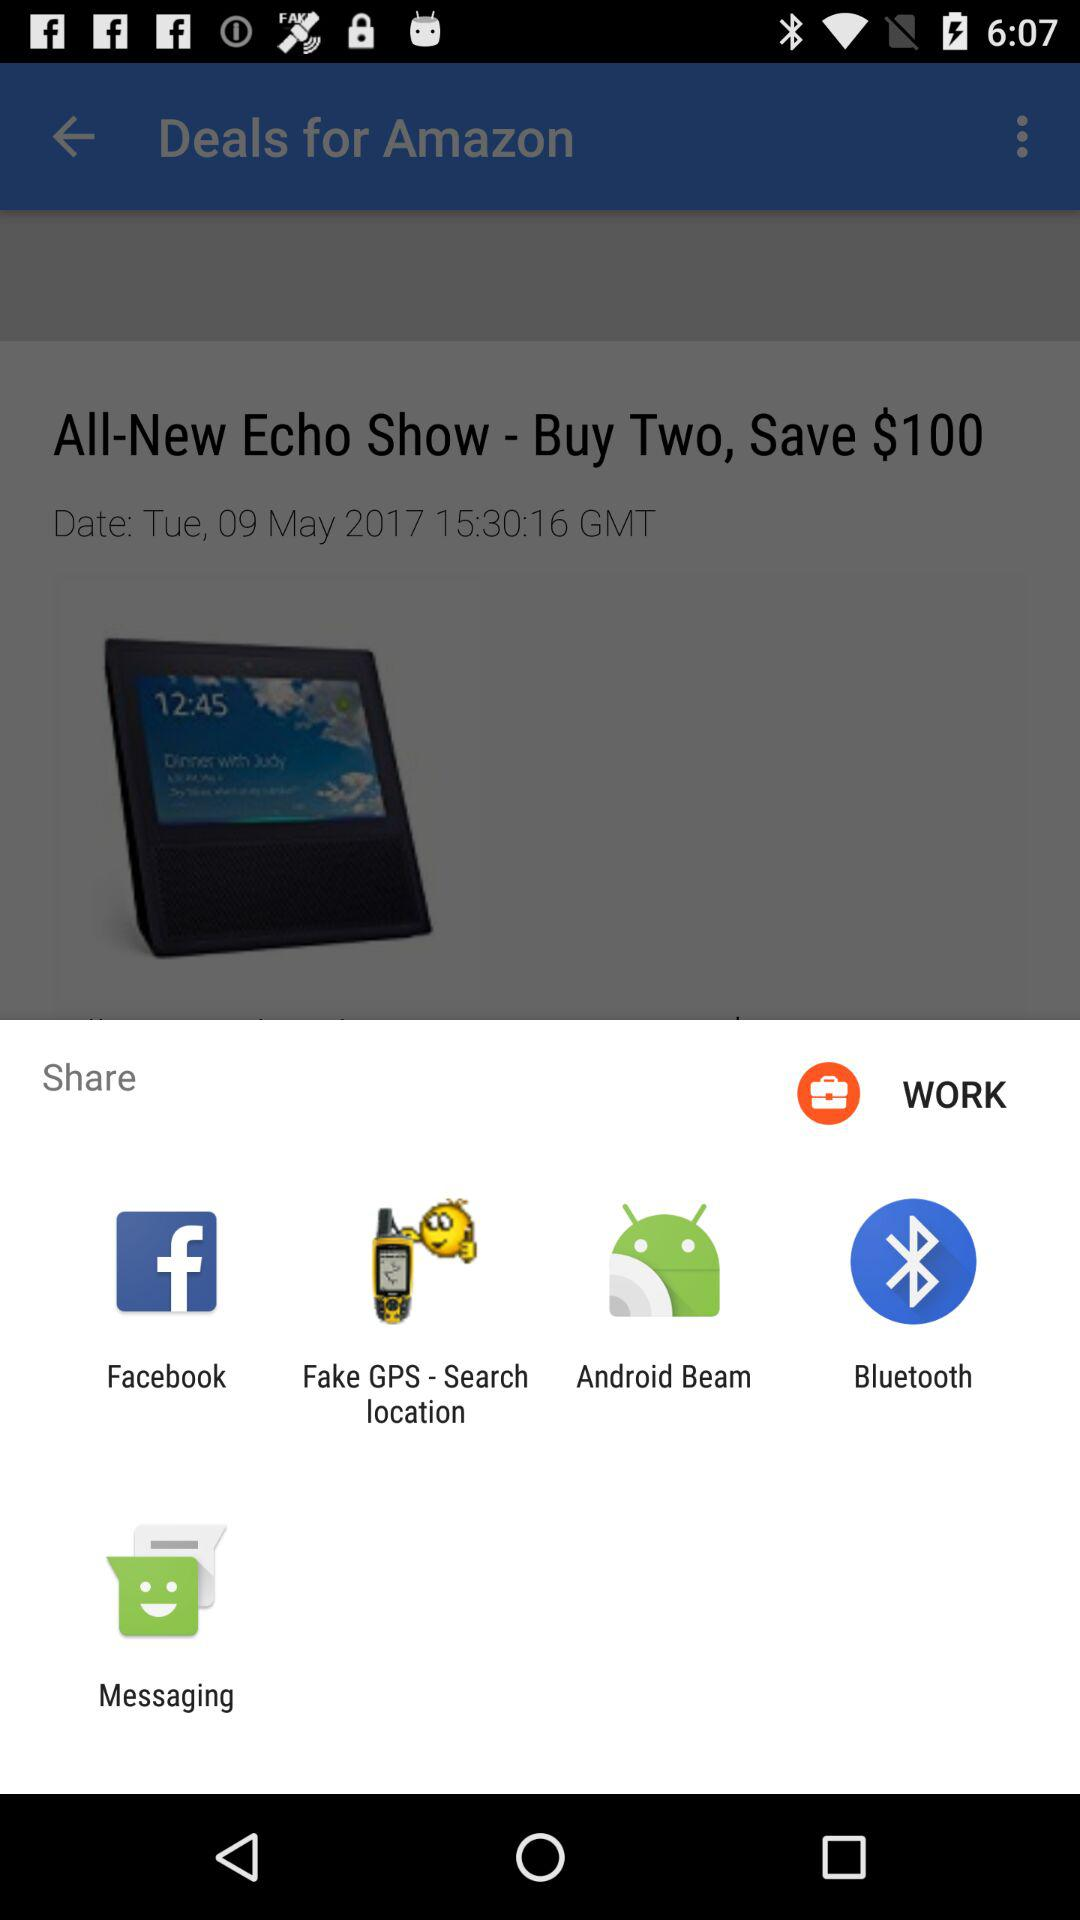Which application can be used to share? You can share with "Facebook", "Fake GPS - Search location", "Android Beam", "Bluetooth" and "Messaging". 